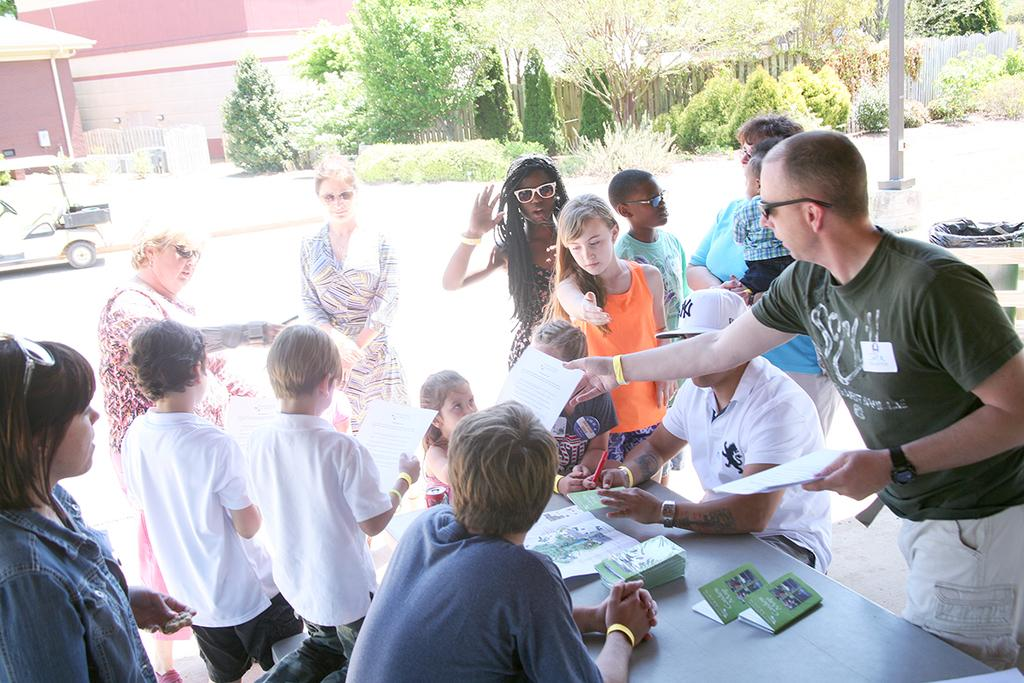What type of structure is visible in the image? There is a building in the image. What is located near the building? There is a fence in the image. What type of natural elements can be seen in the image? There are trees in the image. What mode of transportation is present in the image? There is a car in the image. Are there any people visible in the image? Yes, there are people standing in the image. What object can be seen on the table in the image? There are books on the table in the image. What type of cream is being used to protest in the image? There is no protest or cream present in the image. What is the stick used for in the image? There is no stick present in the image. 